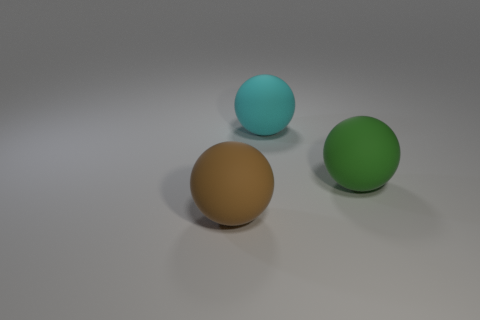Add 2 small cyan shiny things. How many objects exist? 5 Subtract all large brown things. Subtract all small purple metal cylinders. How many objects are left? 2 Add 3 green balls. How many green balls are left? 4 Add 3 cyan spheres. How many cyan spheres exist? 4 Subtract 0 green cylinders. How many objects are left? 3 